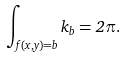<formula> <loc_0><loc_0><loc_500><loc_500>\int _ { f ( x , y ) = b } k _ { b } = 2 \pi .</formula> 